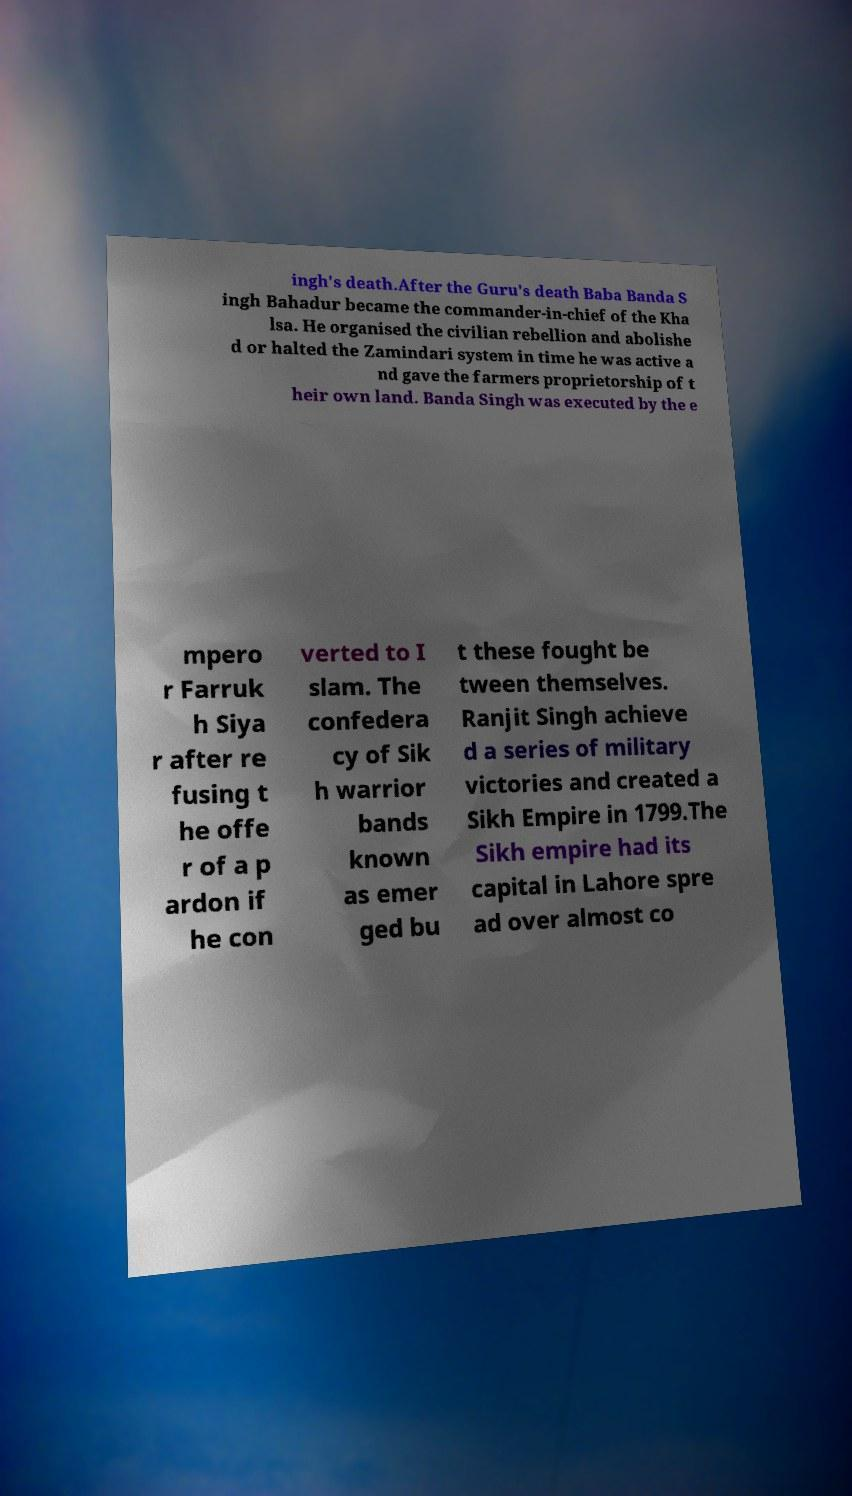Could you assist in decoding the text presented in this image and type it out clearly? ingh's death.After the Guru's death Baba Banda S ingh Bahadur became the commander-in-chief of the Kha lsa. He organised the civilian rebellion and abolishe d or halted the Zamindari system in time he was active a nd gave the farmers proprietorship of t heir own land. Banda Singh was executed by the e mpero r Farruk h Siya r after re fusing t he offe r of a p ardon if he con verted to I slam. The confedera cy of Sik h warrior bands known as emer ged bu t these fought be tween themselves. Ranjit Singh achieve d a series of military victories and created a Sikh Empire in 1799.The Sikh empire had its capital in Lahore spre ad over almost co 